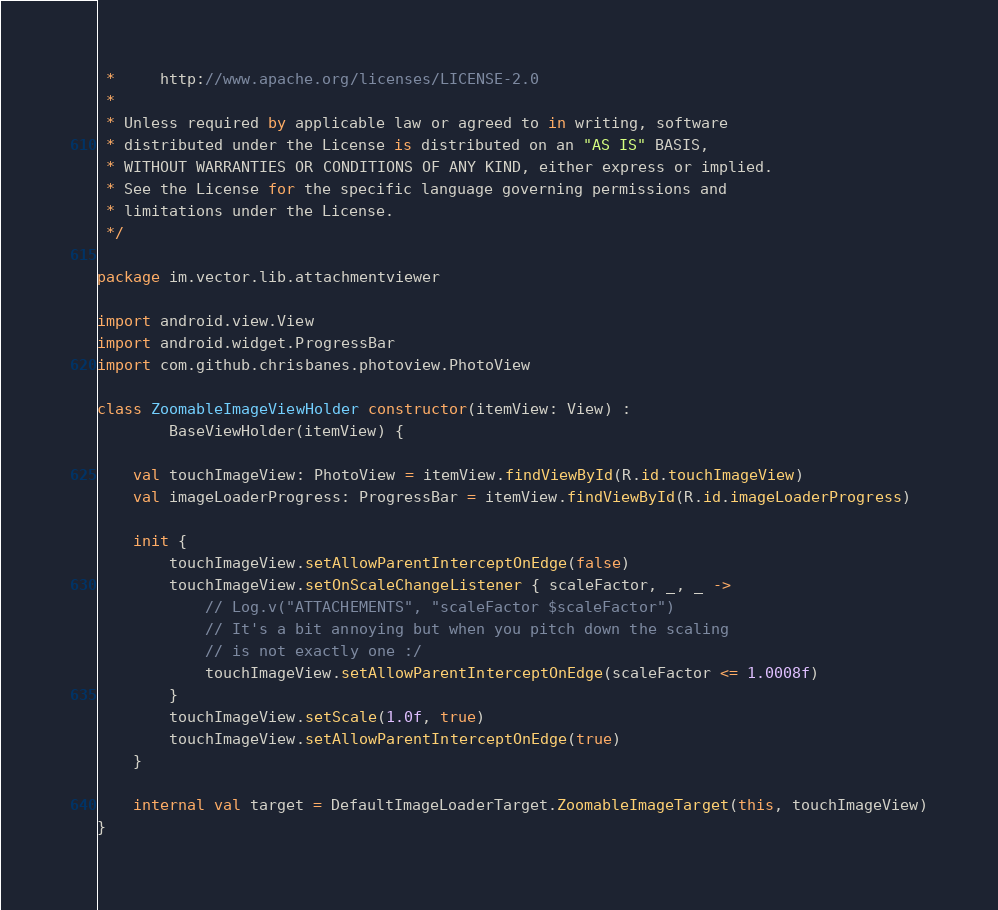Convert code to text. <code><loc_0><loc_0><loc_500><loc_500><_Kotlin_> *     http://www.apache.org/licenses/LICENSE-2.0
 *
 * Unless required by applicable law or agreed to in writing, software
 * distributed under the License is distributed on an "AS IS" BASIS,
 * WITHOUT WARRANTIES OR CONDITIONS OF ANY KIND, either express or implied.
 * See the License for the specific language governing permissions and
 * limitations under the License.
 */

package im.vector.lib.attachmentviewer

import android.view.View
import android.widget.ProgressBar
import com.github.chrisbanes.photoview.PhotoView

class ZoomableImageViewHolder constructor(itemView: View) :
        BaseViewHolder(itemView) {

    val touchImageView: PhotoView = itemView.findViewById(R.id.touchImageView)
    val imageLoaderProgress: ProgressBar = itemView.findViewById(R.id.imageLoaderProgress)

    init {
        touchImageView.setAllowParentInterceptOnEdge(false)
        touchImageView.setOnScaleChangeListener { scaleFactor, _, _ ->
            // Log.v("ATTACHEMENTS", "scaleFactor $scaleFactor")
            // It's a bit annoying but when you pitch down the scaling
            // is not exactly one :/
            touchImageView.setAllowParentInterceptOnEdge(scaleFactor <= 1.0008f)
        }
        touchImageView.setScale(1.0f, true)
        touchImageView.setAllowParentInterceptOnEdge(true)
    }

    internal val target = DefaultImageLoaderTarget.ZoomableImageTarget(this, touchImageView)
}
</code> 